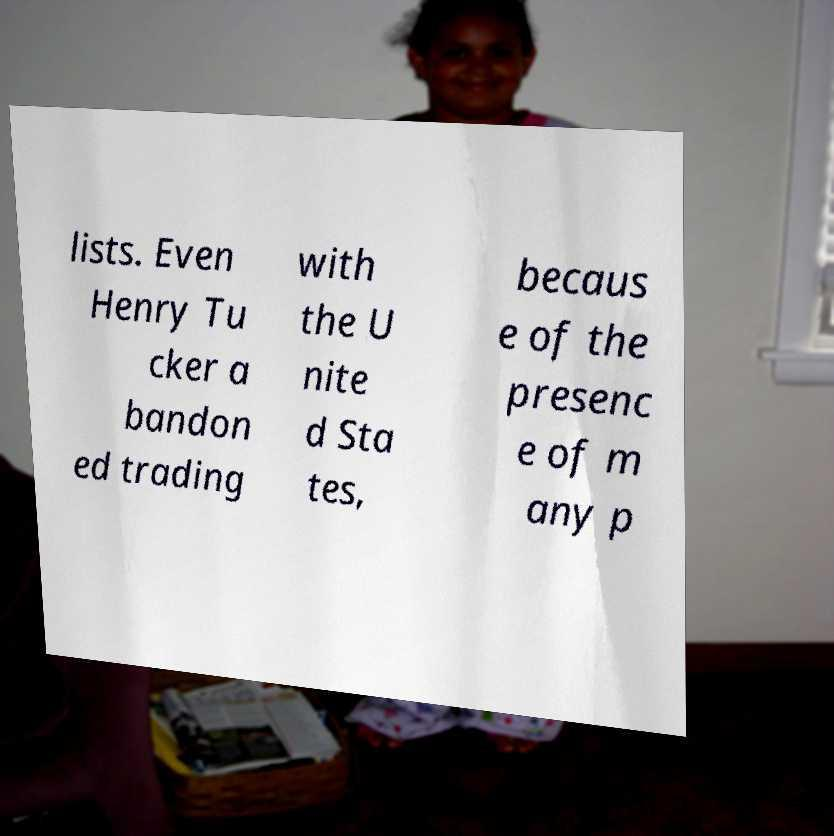Could you assist in decoding the text presented in this image and type it out clearly? lists. Even Henry Tu cker a bandon ed trading with the U nite d Sta tes, becaus e of the presenc e of m any p 